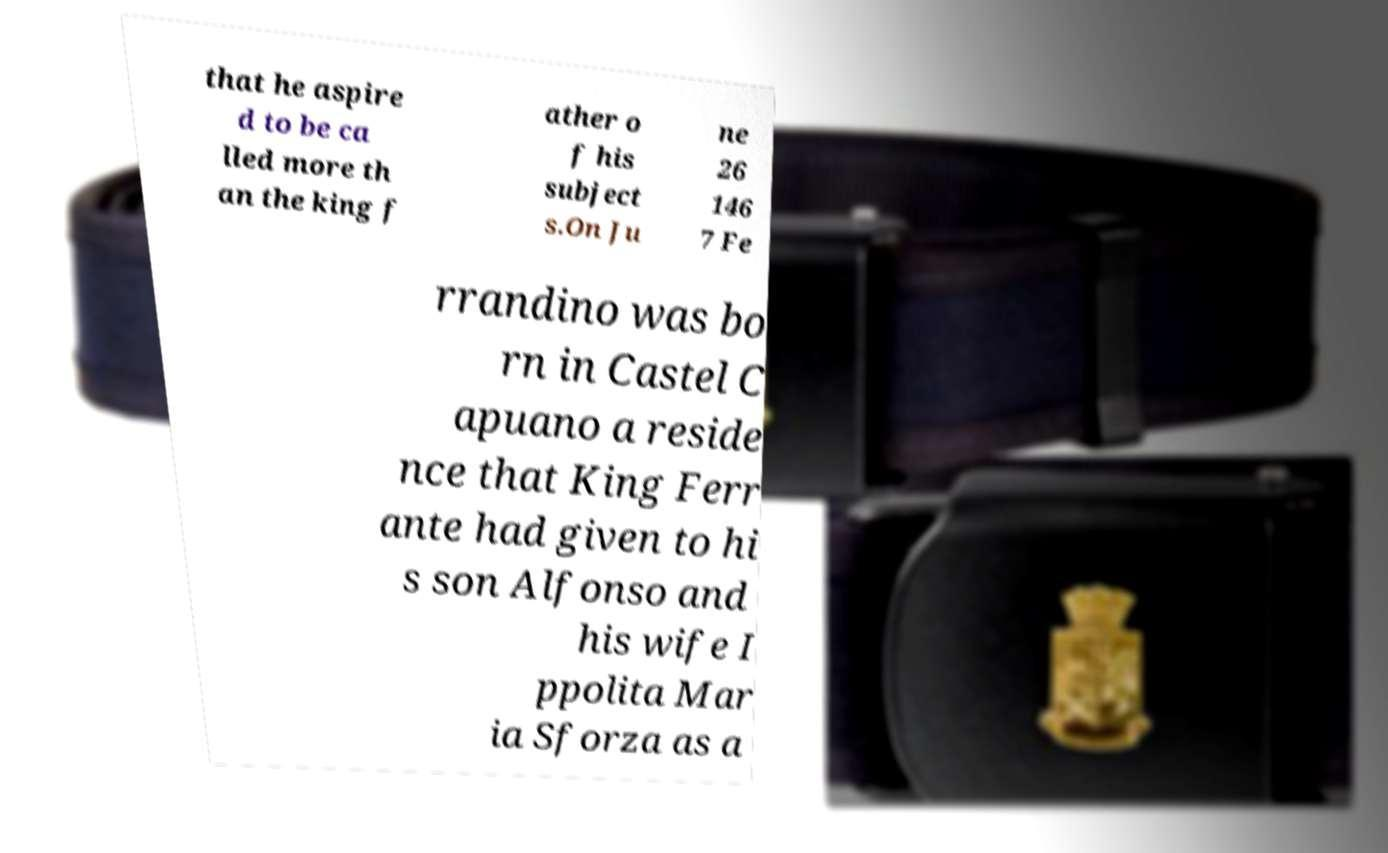I need the written content from this picture converted into text. Can you do that? that he aspire d to be ca lled more th an the king f ather o f his subject s.On Ju ne 26 146 7 Fe rrandino was bo rn in Castel C apuano a reside nce that King Ferr ante had given to hi s son Alfonso and his wife I ppolita Mar ia Sforza as a 